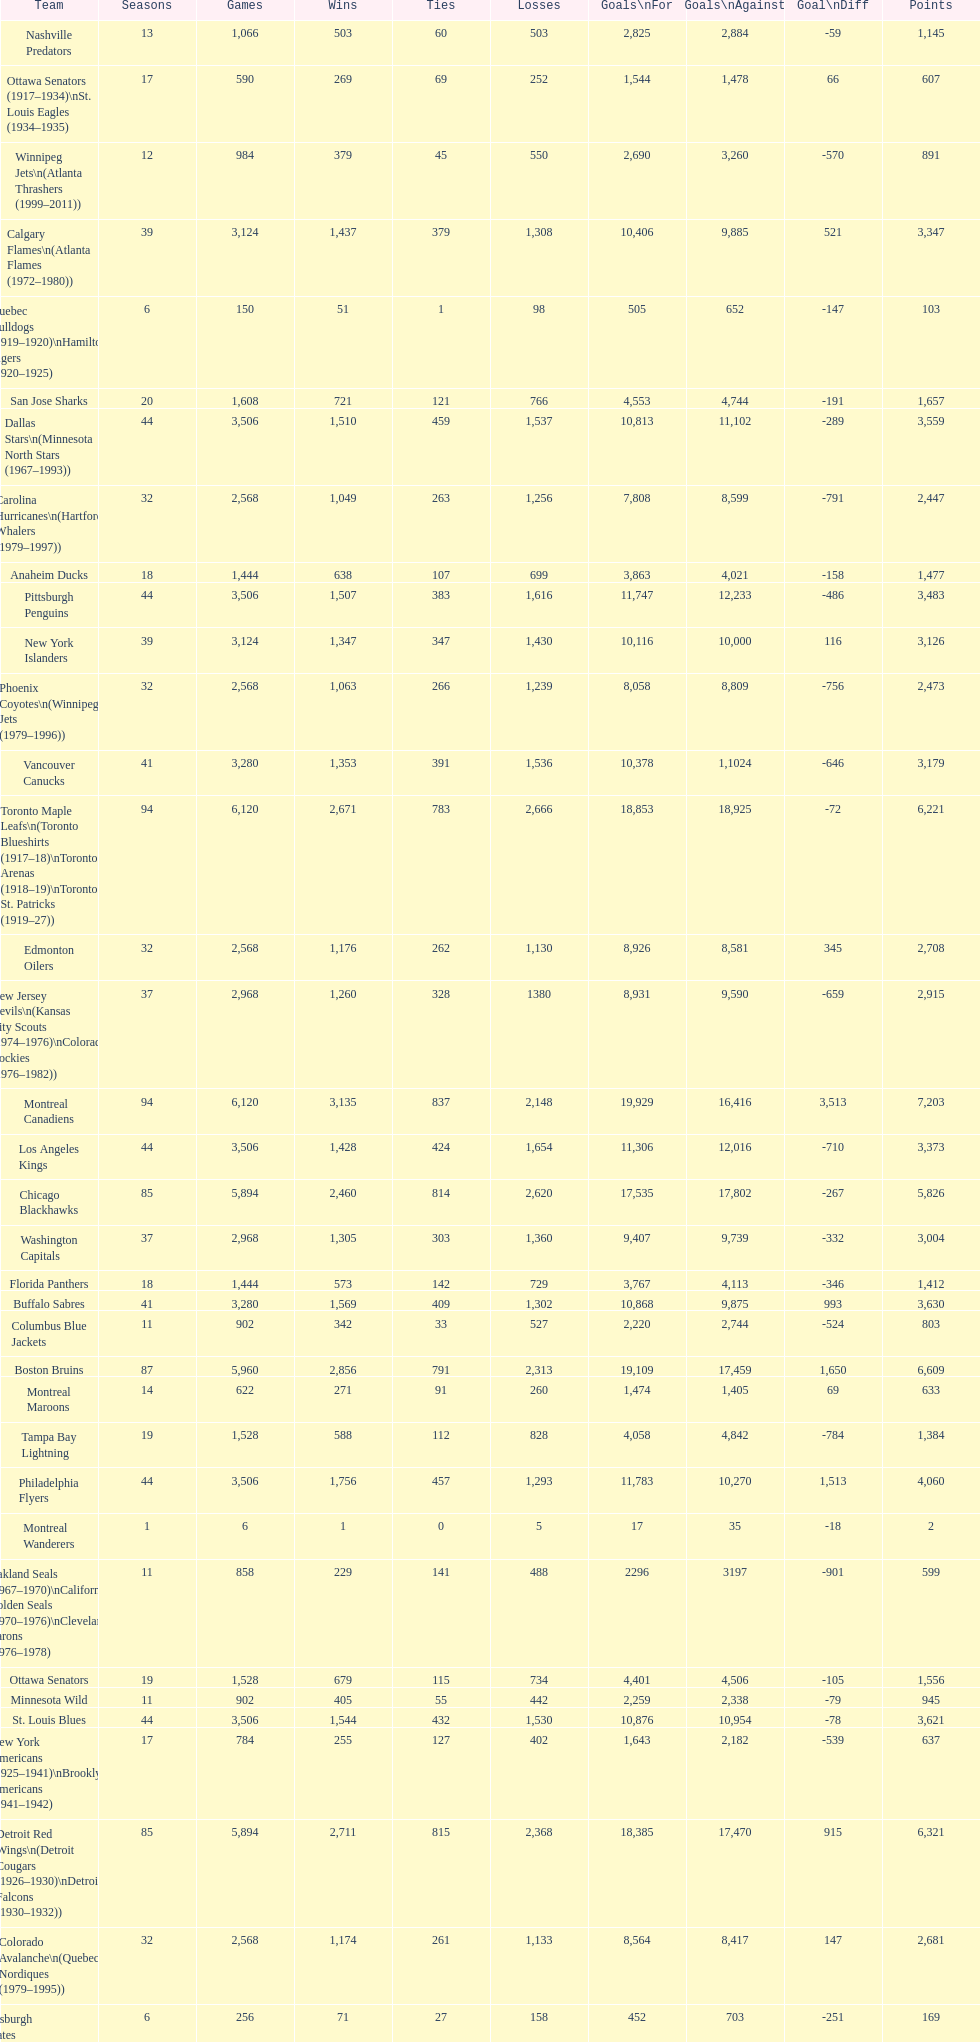Which team played the same amount of seasons as the canadiens? Toronto Maple Leafs. 